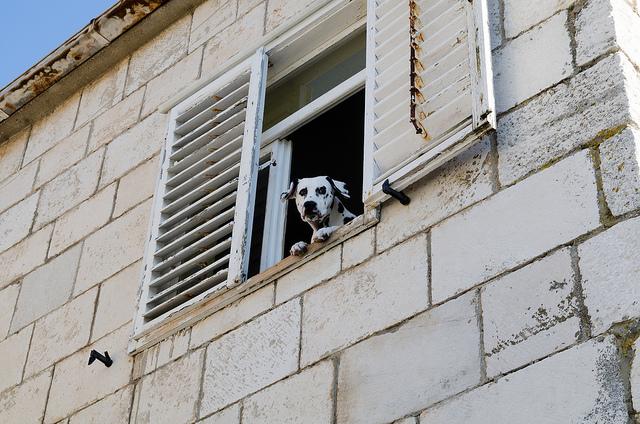What color is this dog?
Quick response, please. Black and white. What kind of dog is looking out the window?
Be succinct. Dalmatian. What is under the window?
Answer briefly. Bricks. What breed is the dog?
Concise answer only. Dalmatian. Is the dog looking out the window?
Short answer required. Yes. 